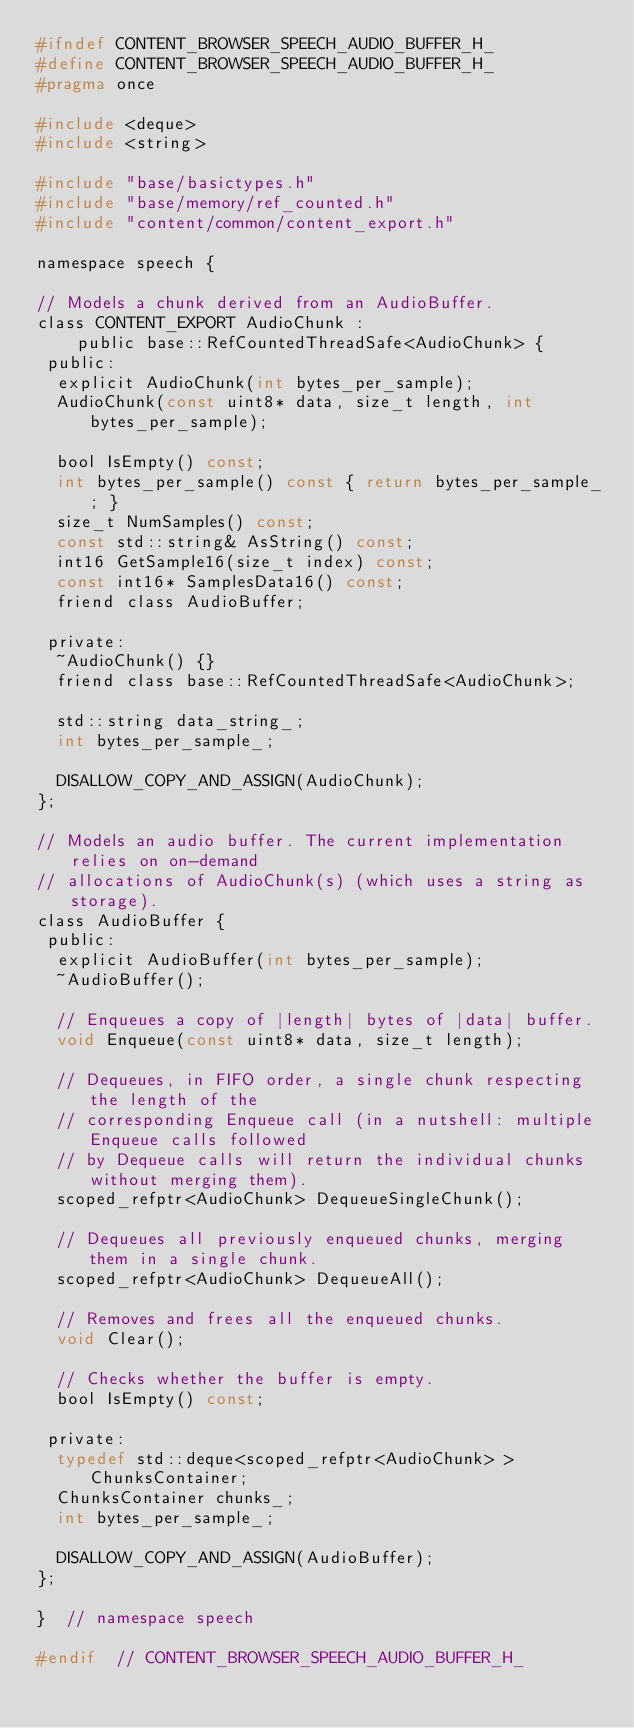Convert code to text. <code><loc_0><loc_0><loc_500><loc_500><_C_>#ifndef CONTENT_BROWSER_SPEECH_AUDIO_BUFFER_H_
#define CONTENT_BROWSER_SPEECH_AUDIO_BUFFER_H_
#pragma once

#include <deque>
#include <string>

#include "base/basictypes.h"
#include "base/memory/ref_counted.h"
#include "content/common/content_export.h"

namespace speech {

// Models a chunk derived from an AudioBuffer.
class CONTENT_EXPORT AudioChunk :
    public base::RefCountedThreadSafe<AudioChunk> {
 public:
  explicit AudioChunk(int bytes_per_sample);
  AudioChunk(const uint8* data, size_t length, int bytes_per_sample);

  bool IsEmpty() const;
  int bytes_per_sample() const { return bytes_per_sample_; }
  size_t NumSamples() const;
  const std::string& AsString() const;
  int16 GetSample16(size_t index) const;
  const int16* SamplesData16() const;
  friend class AudioBuffer;

 private:
  ~AudioChunk() {}
  friend class base::RefCountedThreadSafe<AudioChunk>;

  std::string data_string_;
  int bytes_per_sample_;

  DISALLOW_COPY_AND_ASSIGN(AudioChunk);
};

// Models an audio buffer. The current implementation relies on on-demand
// allocations of AudioChunk(s) (which uses a string as storage).
class AudioBuffer {
 public:
  explicit AudioBuffer(int bytes_per_sample);
  ~AudioBuffer();

  // Enqueues a copy of |length| bytes of |data| buffer.
  void Enqueue(const uint8* data, size_t length);

  // Dequeues, in FIFO order, a single chunk respecting the length of the
  // corresponding Enqueue call (in a nutshell: multiple Enqueue calls followed
  // by Dequeue calls will return the individual chunks without merging them).
  scoped_refptr<AudioChunk> DequeueSingleChunk();

  // Dequeues all previously enqueued chunks, merging them in a single chunk.
  scoped_refptr<AudioChunk> DequeueAll();

  // Removes and frees all the enqueued chunks.
  void Clear();

  // Checks whether the buffer is empty.
  bool IsEmpty() const;

 private:
  typedef std::deque<scoped_refptr<AudioChunk> > ChunksContainer;
  ChunksContainer chunks_;
  int bytes_per_sample_;

  DISALLOW_COPY_AND_ASSIGN(AudioBuffer);
};

}  // namespace speech

#endif  // CONTENT_BROWSER_SPEECH_AUDIO_BUFFER_H_
</code> 